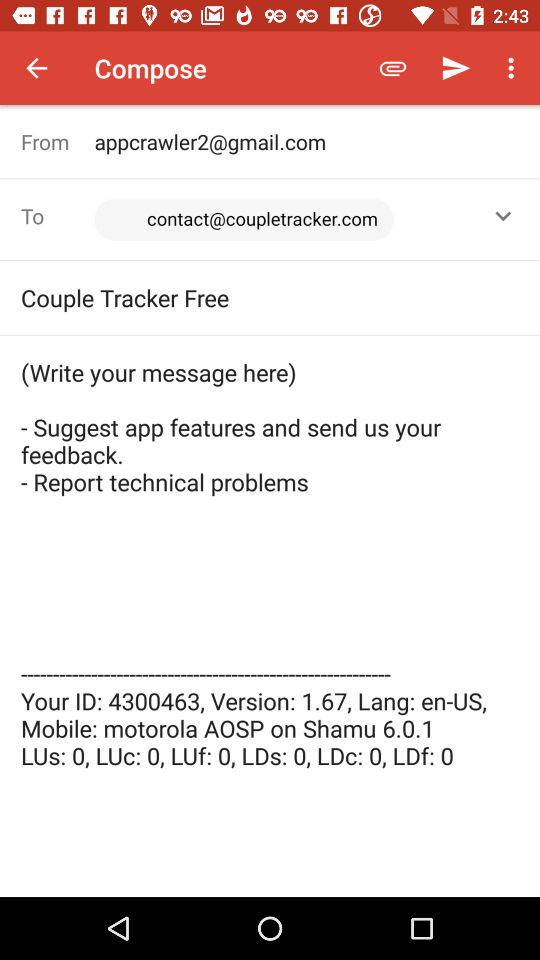What is the email address of the sender and receiver? The email addresses of the sender and receiver are appcrawler2@gmail.com and contact@coupletracker.com, respectively. 